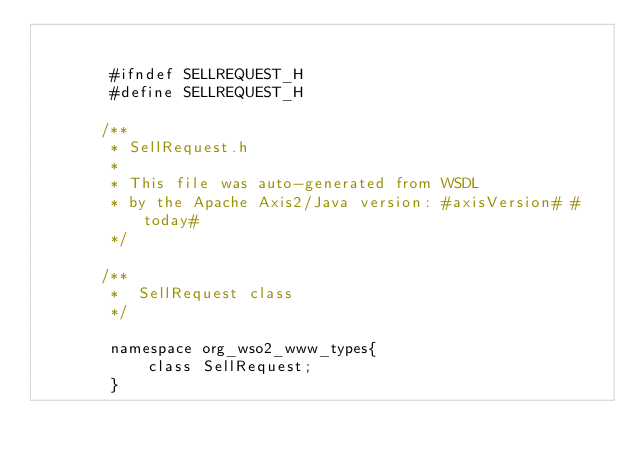<code> <loc_0><loc_0><loc_500><loc_500><_C_>

        #ifndef SELLREQUEST_H
        #define SELLREQUEST_H

       /**
        * SellRequest.h
        *
        * This file was auto-generated from WSDL
        * by the Apache Axis2/Java version: #axisVersion# #today#
        */

       /**
        *  SellRequest class
        */

        namespace org_wso2_www_types{
            class SellRequest;
        }


</code> 